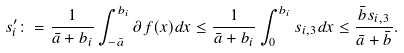Convert formula to latex. <formula><loc_0><loc_0><loc_500><loc_500>s _ { i } ^ { \prime } \colon = \frac { 1 } { \bar { a } + b _ { i } } \int _ { - \bar { a } } ^ { b _ { i } } \partial f ( x ) d x \leq \frac { 1 } { \bar { a } + b _ { i } } \int _ { 0 } ^ { b _ { i } } s _ { i , 3 } d x \leq \frac { \bar { b } s _ { i , 3 } } { \bar { a } + \bar { b } } .</formula> 